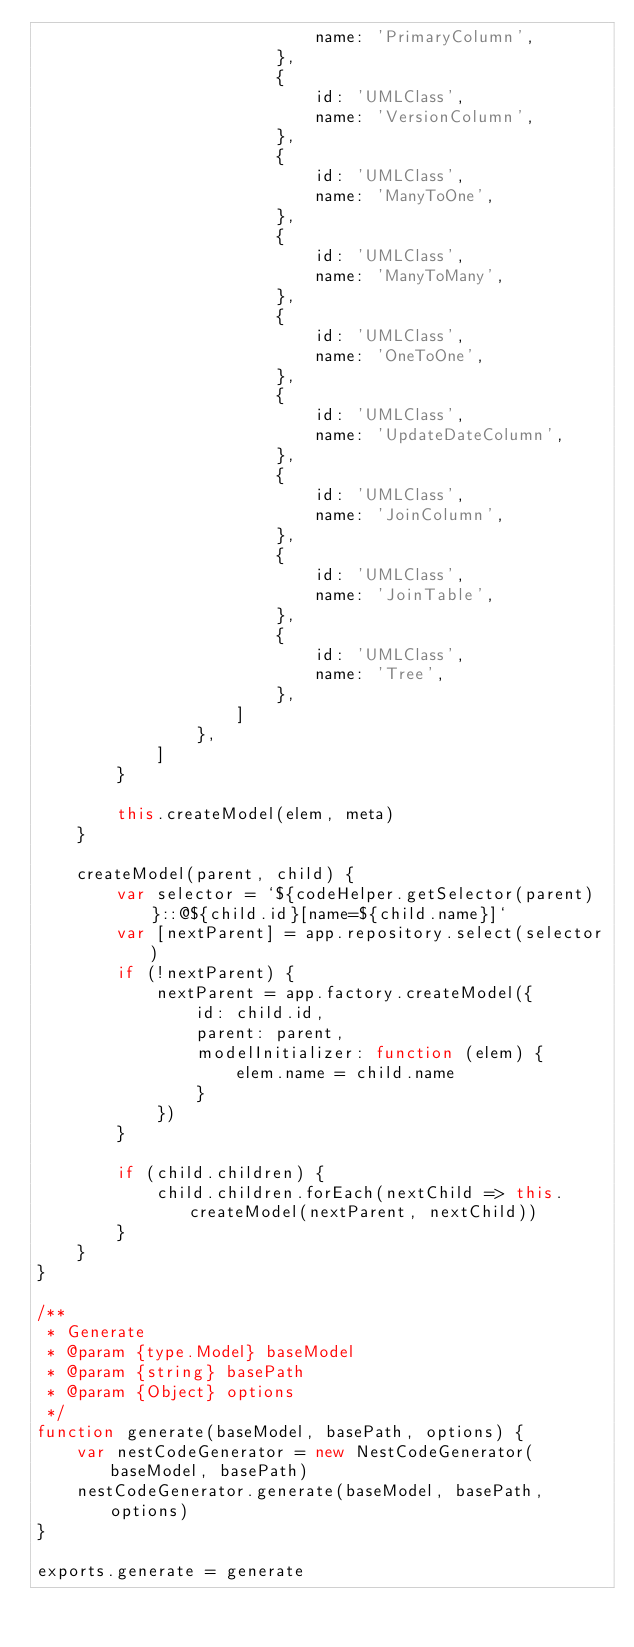Convert code to text. <code><loc_0><loc_0><loc_500><loc_500><_JavaScript_>                            name: 'PrimaryColumn',
                        },
                        {
                            id: 'UMLClass',
                            name: 'VersionColumn',
                        },
                        {
                            id: 'UMLClass',
                            name: 'ManyToOne',
                        },
                        {
                            id: 'UMLClass',
                            name: 'ManyToMany',
                        },
                        {
                            id: 'UMLClass',
                            name: 'OneToOne',
                        },
                        {
                            id: 'UMLClass',
                            name: 'UpdateDateColumn',
                        },
                        {
                            id: 'UMLClass',
                            name: 'JoinColumn',
                        },
                        {
                            id: 'UMLClass',
                            name: 'JoinTable',
                        },
                        {
                            id: 'UMLClass',
                            name: 'Tree',
                        },
                    ]
                },
            ]
        }

        this.createModel(elem, meta)
    }

    createModel(parent, child) {
        var selector = `${codeHelper.getSelector(parent)}::@${child.id}[name=${child.name}]`
        var [nextParent] = app.repository.select(selector)
        if (!nextParent) {
            nextParent = app.factory.createModel({
                id: child.id,
                parent: parent,
                modelInitializer: function (elem) {
                    elem.name = child.name
                }
            })
        }

        if (child.children) {
            child.children.forEach(nextChild => this.createModel(nextParent, nextChild))
        }
    }
}

/**
 * Generate
 * @param {type.Model} baseModel
 * @param {string} basePath
 * @param {Object} options
 */
function generate(baseModel, basePath, options) {
    var nestCodeGenerator = new NestCodeGenerator(baseModel, basePath)
    nestCodeGenerator.generate(baseModel, basePath, options)
}

exports.generate = generate
</code> 